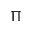<formula> <loc_0><loc_0><loc_500><loc_500>\Pi</formula> 